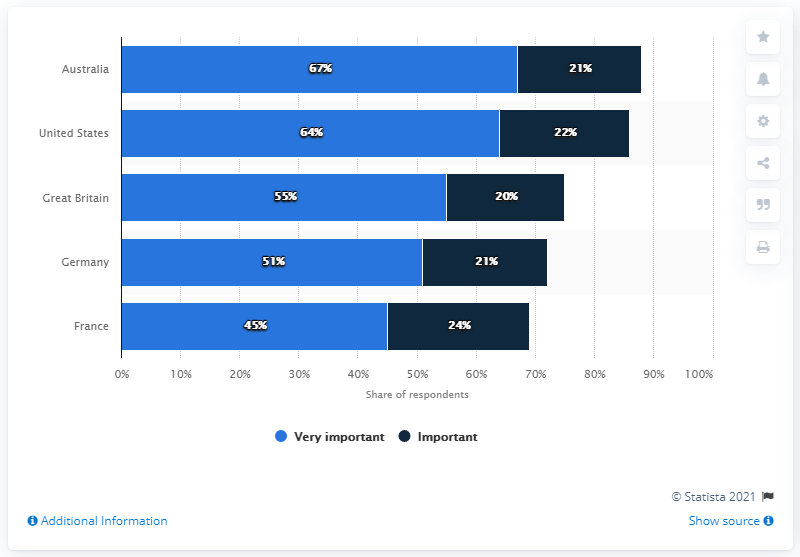List a handful of essential elements in this visual. The important rate was highest in France. The highest important and the lowest very important are different. 